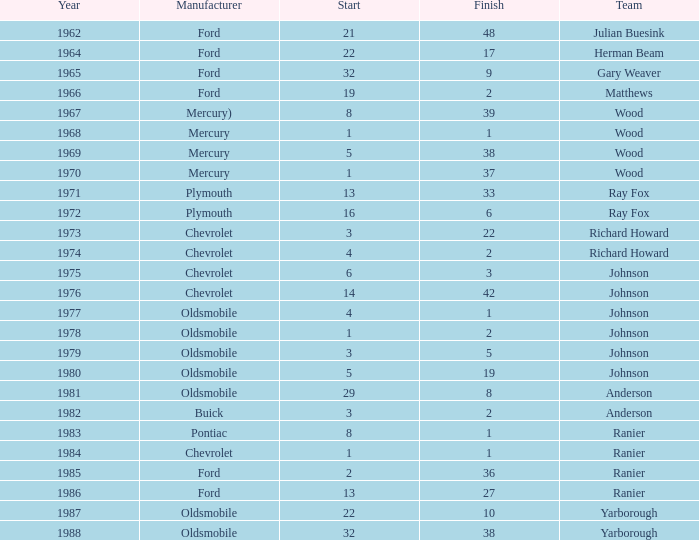What is the shortest end time for a competition where the initiation was below 3, buick was the maker, and the contest occurred after 1978? None. 